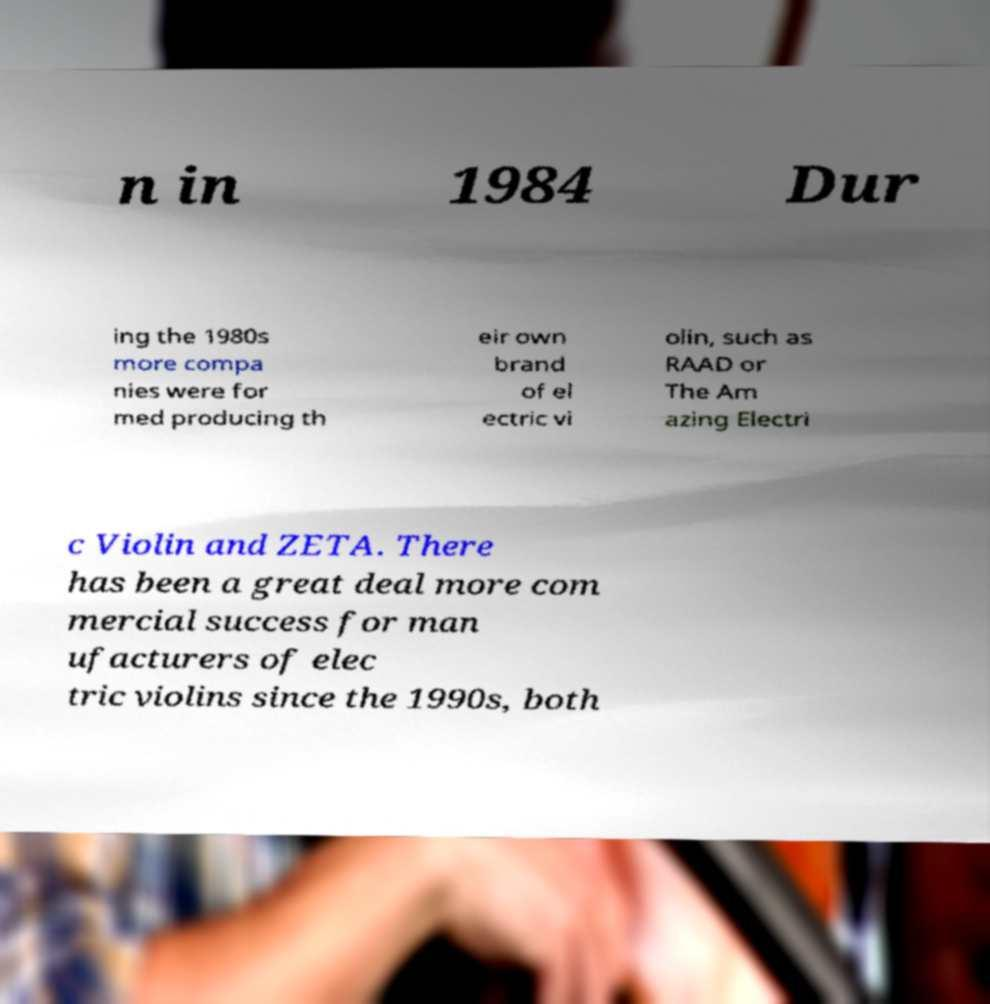For documentation purposes, I need the text within this image transcribed. Could you provide that? n in 1984 Dur ing the 1980s more compa nies were for med producing th eir own brand of el ectric vi olin, such as RAAD or The Am azing Electri c Violin and ZETA. There has been a great deal more com mercial success for man ufacturers of elec tric violins since the 1990s, both 